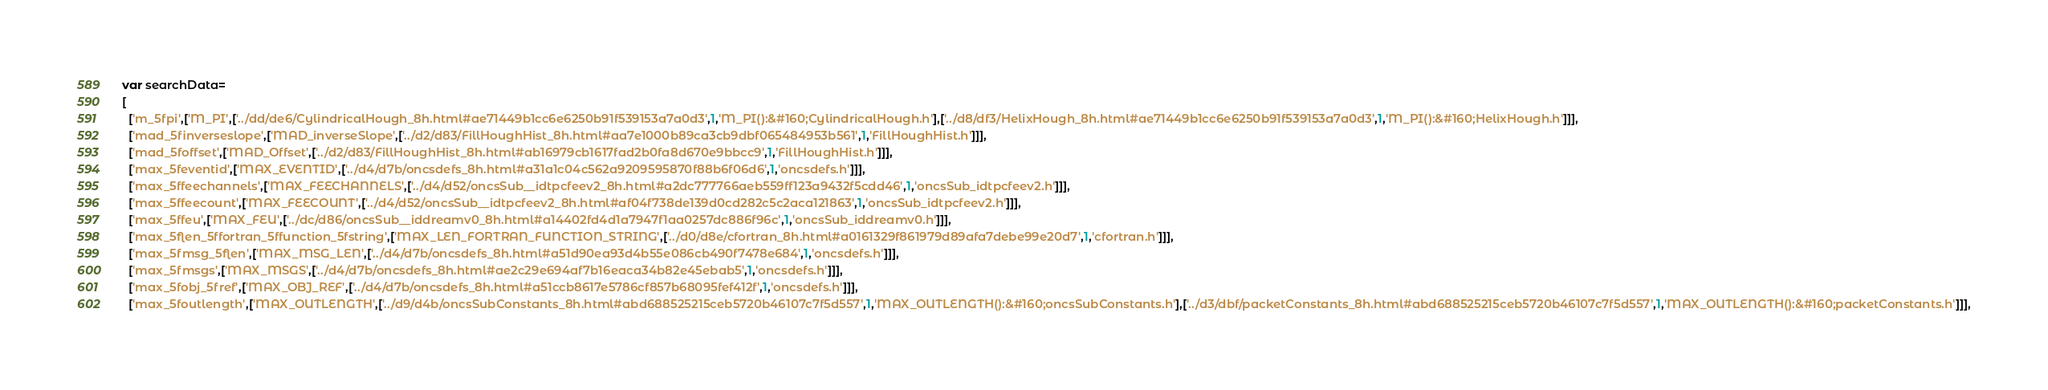Convert code to text. <code><loc_0><loc_0><loc_500><loc_500><_JavaScript_>var searchData=
[
  ['m_5fpi',['M_PI',['../dd/de6/CylindricalHough_8h.html#ae71449b1cc6e6250b91f539153a7a0d3',1,'M_PI():&#160;CylindricalHough.h'],['../d8/df3/HelixHough_8h.html#ae71449b1cc6e6250b91f539153a7a0d3',1,'M_PI():&#160;HelixHough.h']]],
  ['mad_5finverseslope',['MAD_inverseSlope',['../d2/d83/FillHoughHist_8h.html#aa7e1000b89ca3cb9dbf065484953b561',1,'FillHoughHist.h']]],
  ['mad_5foffset',['MAD_Offset',['../d2/d83/FillHoughHist_8h.html#ab16979cb1617fad2b0fa8d670e9bbcc9',1,'FillHoughHist.h']]],
  ['max_5feventid',['MAX_EVENTID',['../d4/d7b/oncsdefs_8h.html#a31a1c04c562a9209595870f88b6f06d6',1,'oncsdefs.h']]],
  ['max_5ffeechannels',['MAX_FEECHANNELS',['../d4/d52/oncsSub__idtpcfeev2_8h.html#a2dc777766aeb559ff123a9432f5cdd46',1,'oncsSub_idtpcfeev2.h']]],
  ['max_5ffeecount',['MAX_FEECOUNT',['../d4/d52/oncsSub__idtpcfeev2_8h.html#af04f738de139d0cd282c5c2aca121863',1,'oncsSub_idtpcfeev2.h']]],
  ['max_5ffeu',['MAX_FEU',['../dc/d86/oncsSub__iddreamv0_8h.html#a14402fd4d1a7947f1aa0257dc886f96c',1,'oncsSub_iddreamv0.h']]],
  ['max_5flen_5ffortran_5ffunction_5fstring',['MAX_LEN_FORTRAN_FUNCTION_STRING',['../d0/d8e/cfortran_8h.html#a0161329f861979d89afa7debe99e20d7',1,'cfortran.h']]],
  ['max_5fmsg_5flen',['MAX_MSG_LEN',['../d4/d7b/oncsdefs_8h.html#a51d90ea93d4b55e086cb490f7478e684',1,'oncsdefs.h']]],
  ['max_5fmsgs',['MAX_MSGS',['../d4/d7b/oncsdefs_8h.html#ae2c29e694af7b16eaca34b82e45ebab5',1,'oncsdefs.h']]],
  ['max_5fobj_5fref',['MAX_OBJ_REF',['../d4/d7b/oncsdefs_8h.html#a51ccb8617e5786cf857b68095fef412f',1,'oncsdefs.h']]],
  ['max_5foutlength',['MAX_OUTLENGTH',['../d9/d4b/oncsSubConstants_8h.html#abd688525215ceb5720b46107c7f5d557',1,'MAX_OUTLENGTH():&#160;oncsSubConstants.h'],['../d3/dbf/packetConstants_8h.html#abd688525215ceb5720b46107c7f5d557',1,'MAX_OUTLENGTH():&#160;packetConstants.h']]],</code> 